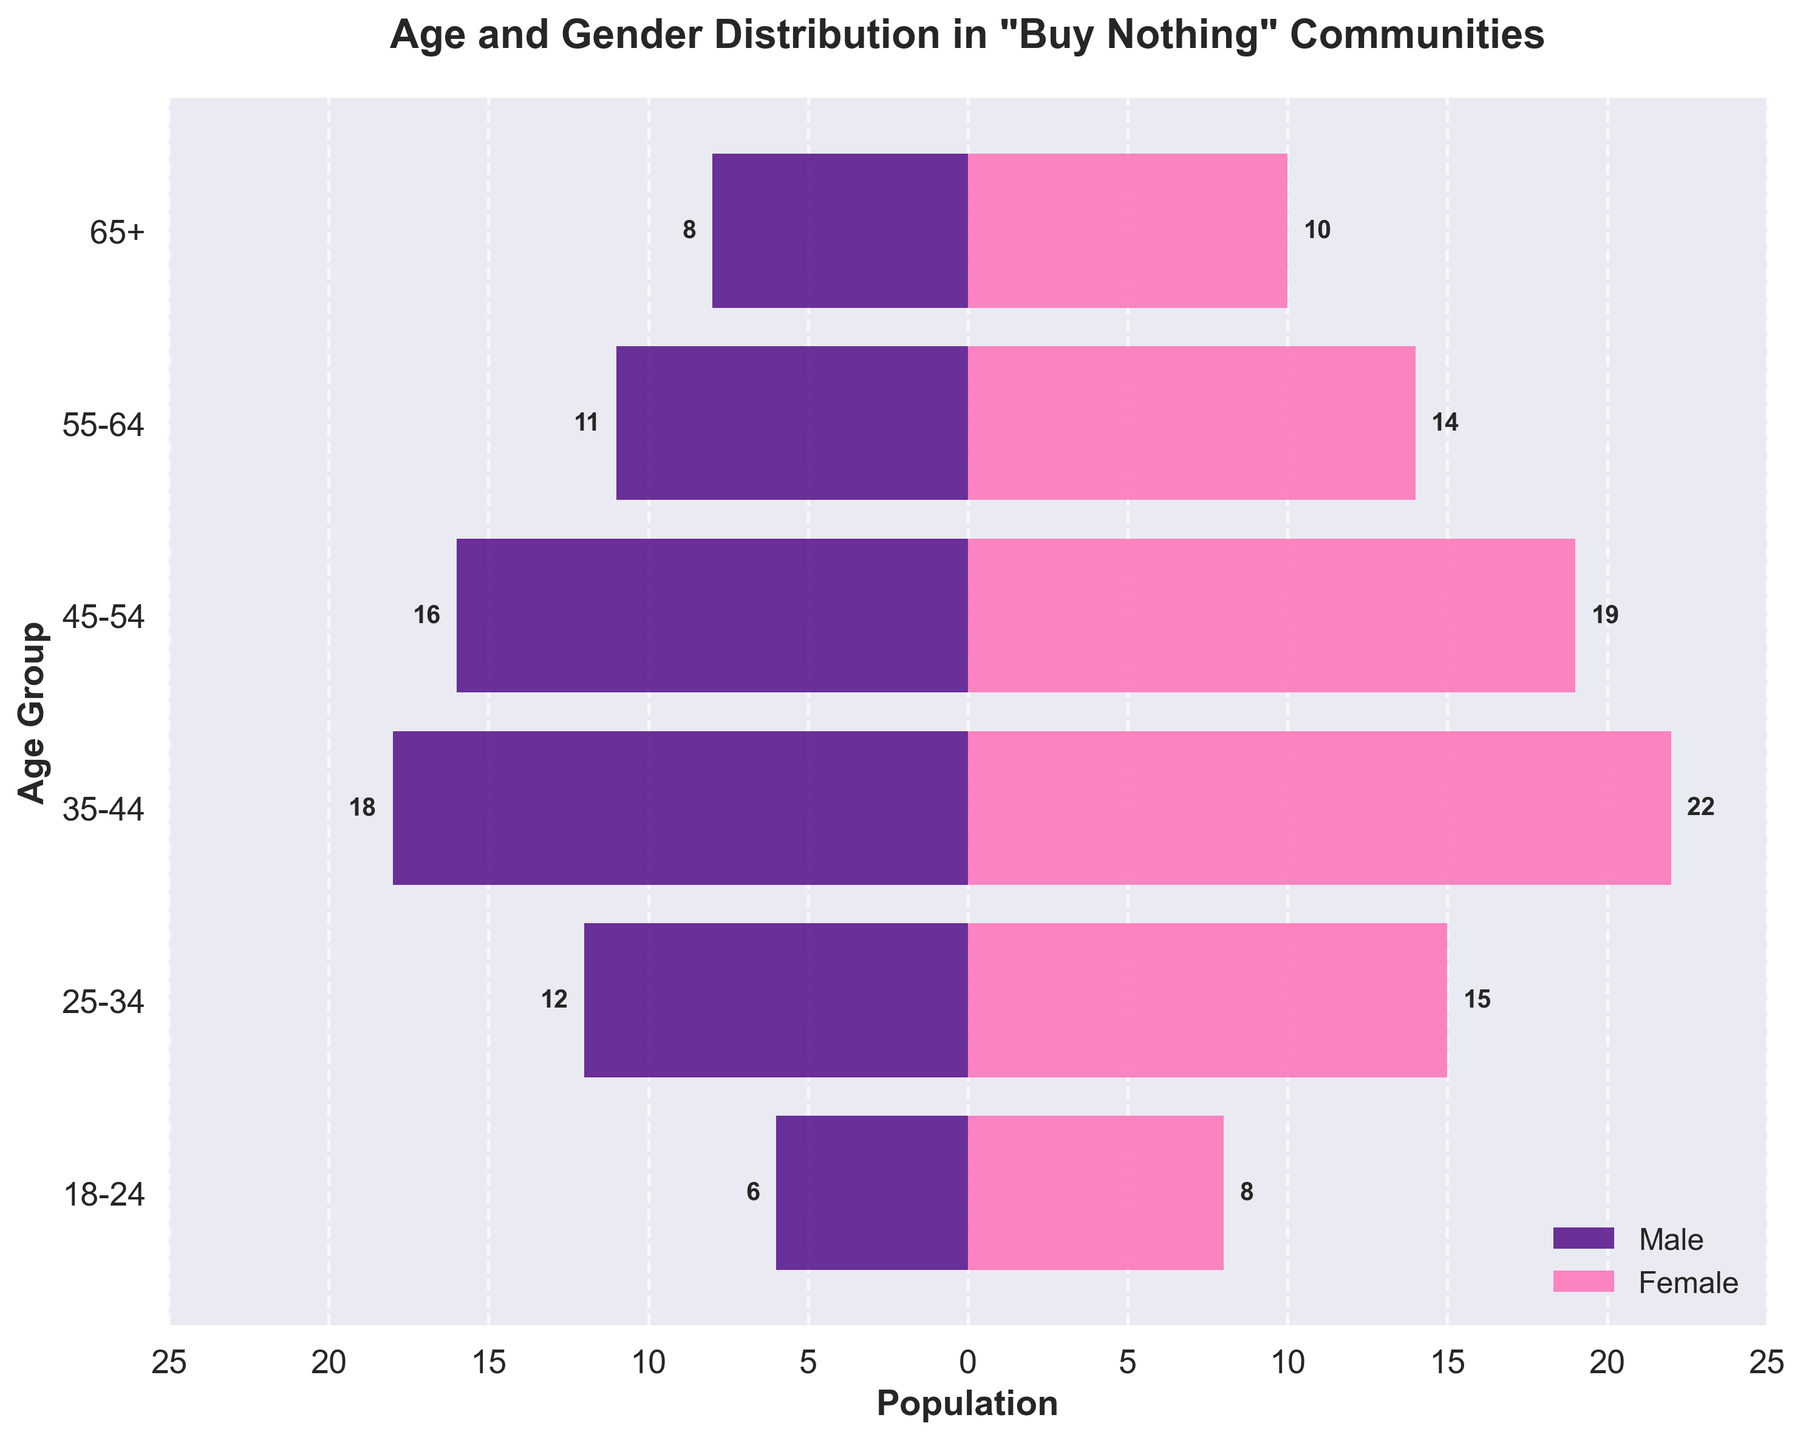What is the title of the plot? The title is located at the top of the plot. It is often a clear descriptor of what the plot represents. In this case, it says "Age and Gender Distribution in 'Buy Nothing' Communities."
Answer: Age and Gender Distribution in "Buy Nothing" Communities What colors represent male and female on the plot? The plot uses two distinct colors for the genders. The male bars are in purple, and the female bars are in pink.
Answer: Purple for male and pink for female Which age group has the highest number of individuals participating in the "Buy Nothing" communities? To find this, look for the age group with the longest bars combined (both male and female) on the horizontal axis. The 35-44 age group has the longest total bars.
Answer: 35-44 What's the ratio of males to females in the 18-24 age group? The number of females in the 18-24 age group is 8, and the number of males is 6. The ratio is calculated by dividing the number of males by females: 6/8 = 0.75.
Answer: 0.75 How many age groups are represented in the plot? Count the distinct horizontal bars which represent each age group. There are six age groups in the plot.
Answer: Six What is the age group with the smallest female population? Look at the pink bars and find the shortest one. The age group 65+ has the smallest female population, with 10 individuals.
Answer: 65+ How does the population of males aged 45-54 compare to females aged 18-24? The male population aged 45-54 is 16, while the female population aged 18-24 is 8. Comparing these, 16 is greater than 8.
Answer: 16 males aged 45-54 are more than 8 females aged 18-24 What is the total number of participants in the 25-34 age group? Add the number of males and females in the 25-34 age group. The number of males is 12, and females are 15. So, 12 + 15 = 27.
Answer: 27 Which gender has more participants in the 55-64 age group, and by how much? Compare the length of the bars for male and female in the 55-64 age group. Females have 14 participants, and males have 11. Subtract the number of males from females, 14 - 11 = 3.
Answer: Females, by 3 